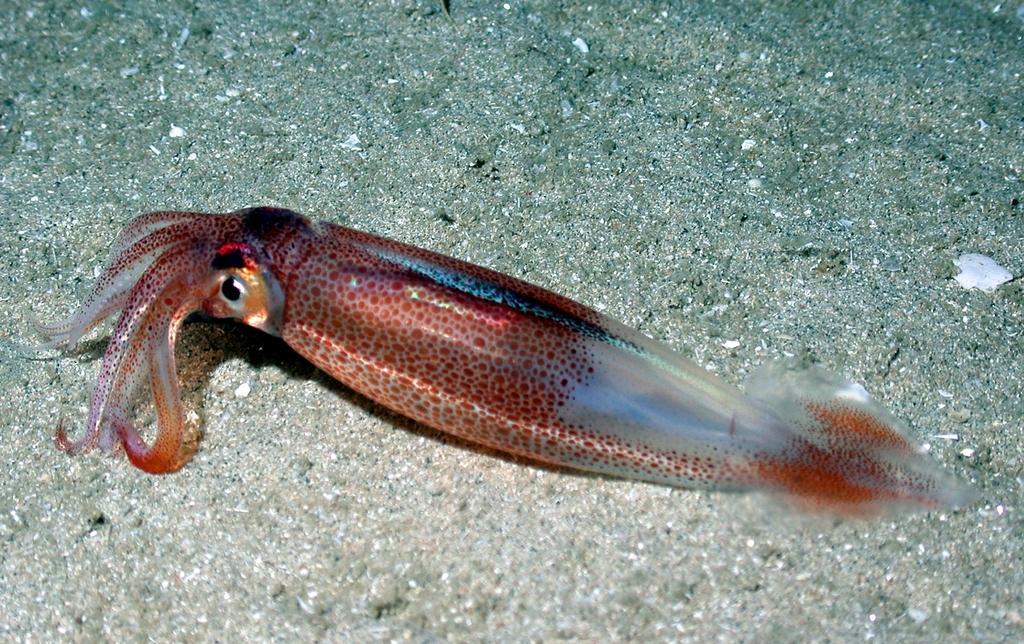In one or two sentences, can you explain what this image depicts? In this image we can see a fish. 